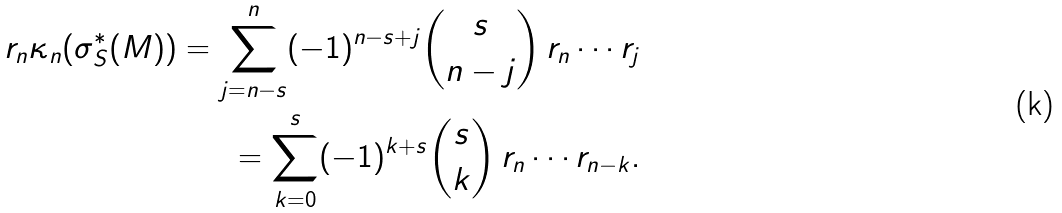Convert formula to latex. <formula><loc_0><loc_0><loc_500><loc_500>r _ { n } \kappa _ { n } ( \sigma _ { S } ^ { * } ( M ) ) = \sum _ { j = n - s } ^ { n } ( - 1 ) ^ { n - s + j } \binom { s } { n - j } \, r _ { n } \cdots r _ { j } \\ = \sum _ { k = 0 } ^ { s } ( - 1 ) ^ { k + s } \binom { s } { k } \, r _ { n } \cdots r _ { n - k } .</formula> 